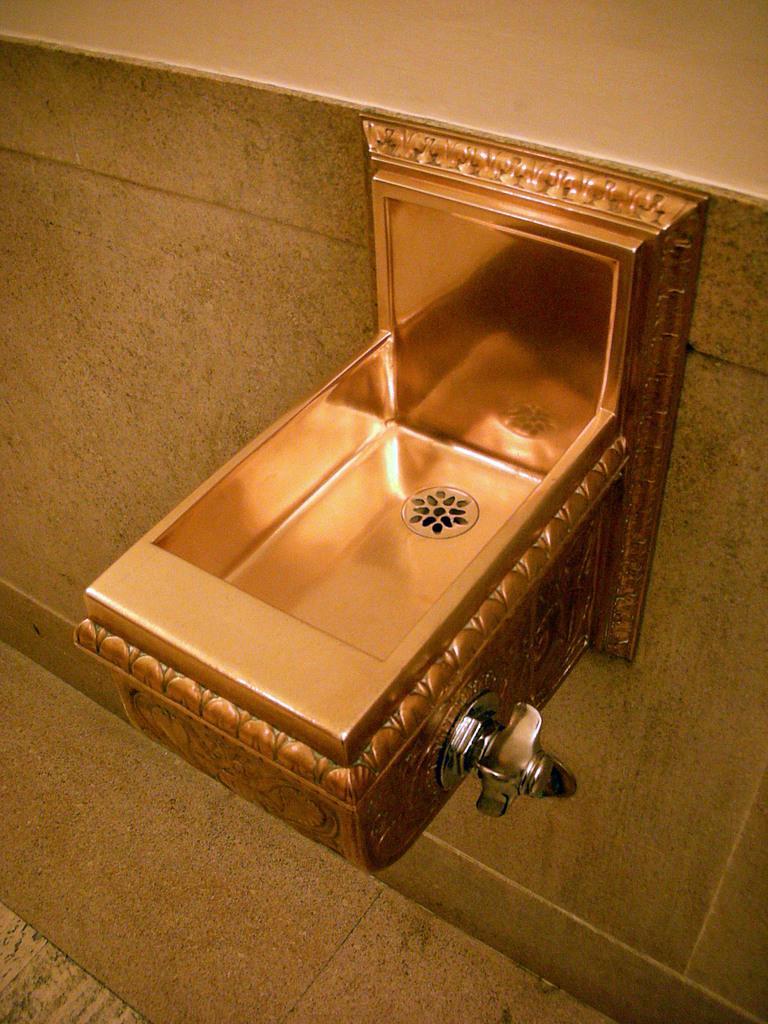How would you summarize this image in a sentence or two? This image is clicked in the washroom. In the front, there is a sink. At the bottom, there is a floor. The sink is fixed to the wall. 